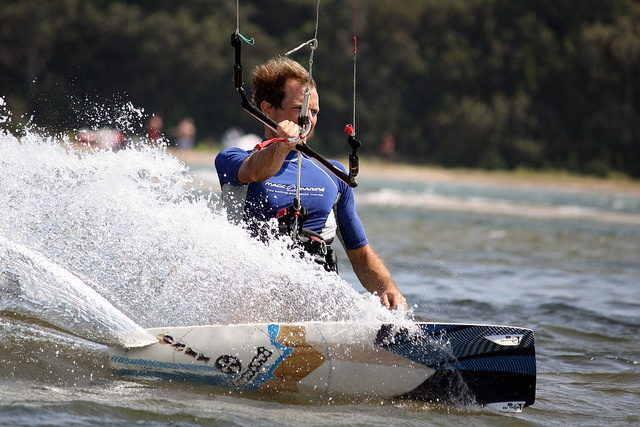Describe the objects in this image and their specific colors. I can see surfboard in black, gray, darkgray, and lightgray tones and people in black, white, maroon, and gray tones in this image. 